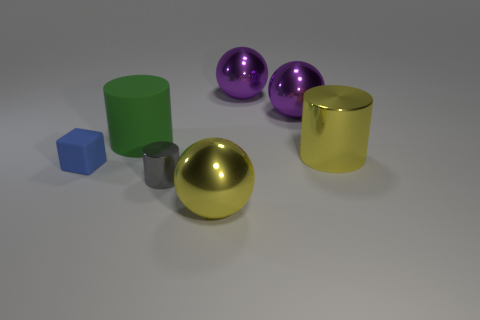Subtract all big yellow cylinders. How many cylinders are left? 2 Subtract all purple spheres. How many spheres are left? 1 Add 3 large purple balls. How many objects exist? 10 Subtract 3 cylinders. How many cylinders are left? 0 Add 2 small metal things. How many small metal things are left? 3 Add 2 tiny rubber things. How many tiny rubber things exist? 3 Subtract 1 green cylinders. How many objects are left? 6 Subtract all cubes. How many objects are left? 6 Subtract all brown cylinders. Subtract all green balls. How many cylinders are left? 3 Subtract all blue spheres. How many yellow cylinders are left? 1 